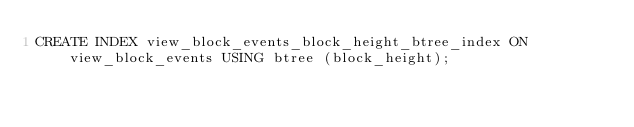Convert code to text. <code><loc_0><loc_0><loc_500><loc_500><_SQL_>CREATE INDEX view_block_events_block_height_btree_index ON view_block_events USING btree (block_height);
</code> 